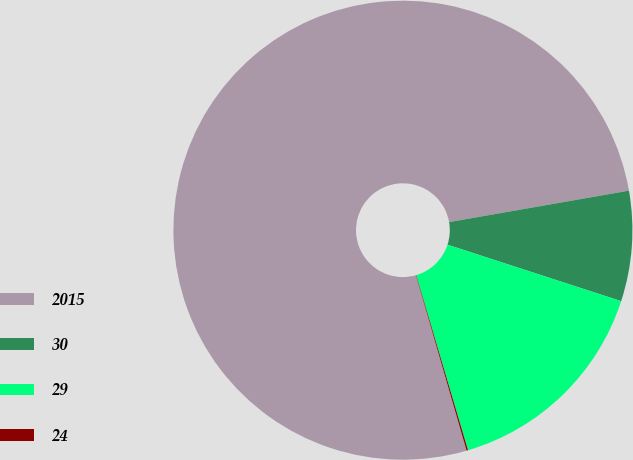Convert chart to OTSL. <chart><loc_0><loc_0><loc_500><loc_500><pie_chart><fcel>2015<fcel>30<fcel>29<fcel>24<nl><fcel>76.72%<fcel>7.76%<fcel>15.42%<fcel>0.1%<nl></chart> 